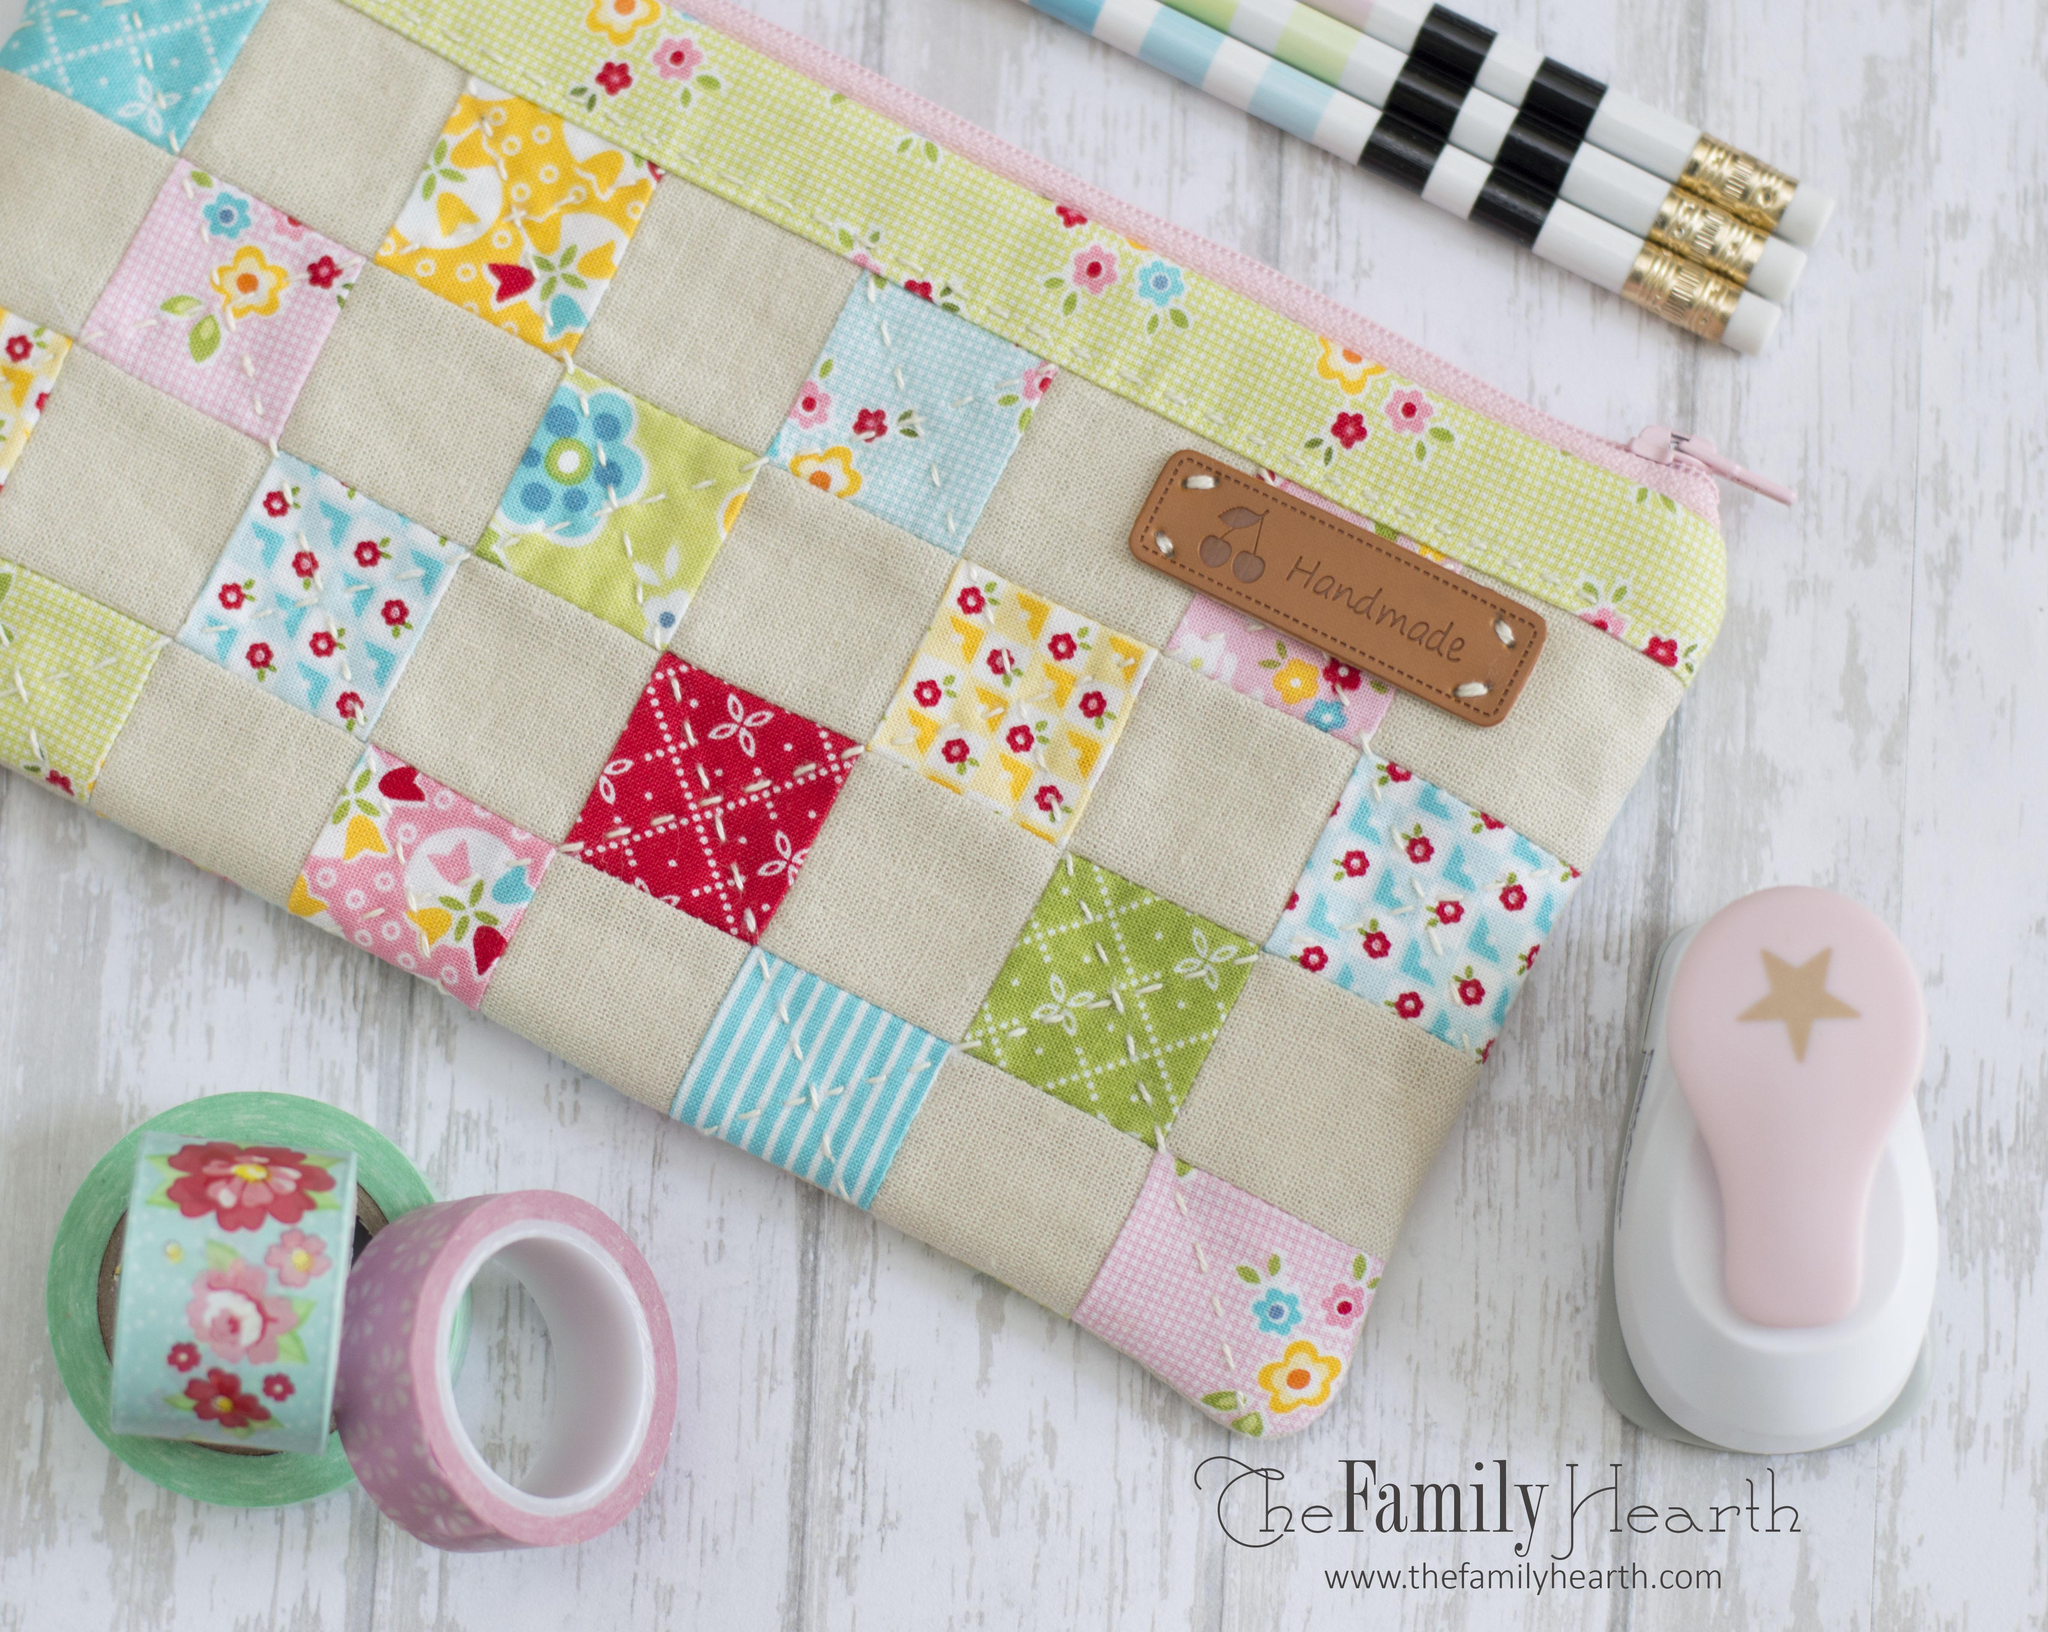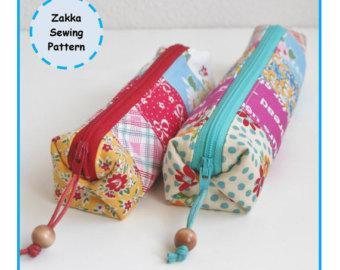The first image is the image on the left, the second image is the image on the right. Given the left and right images, does the statement "One image shows two tube-shaped zipper cases with patchwork patterns displayed end-first, and the other image shows one flat zipper case with a patterned exterior." hold true? Answer yes or no. Yes. The first image is the image on the left, the second image is the image on the right. Examine the images to the left and right. Is the description "Exactly one pouch is open with office supplies sticking out." accurate? Answer yes or no. No. 